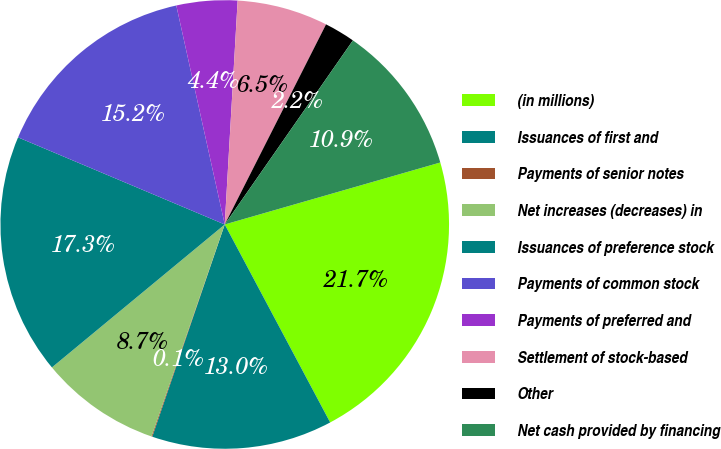Convert chart to OTSL. <chart><loc_0><loc_0><loc_500><loc_500><pie_chart><fcel>(in millions)<fcel>Issuances of first and<fcel>Payments of senior notes<fcel>Net increases (decreases) in<fcel>Issuances of preference stock<fcel>Payments of common stock<fcel>Payments of preferred and<fcel>Settlement of stock-based<fcel>Other<fcel>Net cash provided by financing<nl><fcel>21.66%<fcel>13.02%<fcel>0.06%<fcel>8.7%<fcel>17.34%<fcel>15.18%<fcel>4.38%<fcel>6.54%<fcel>2.22%<fcel>10.86%<nl></chart> 